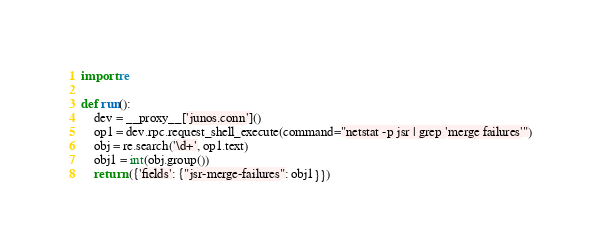Convert code to text. <code><loc_0><loc_0><loc_500><loc_500><_Python_>import re

def run():
    dev = __proxy__['junos.conn']()
    op1 = dev.rpc.request_shell_execute(command="netstat -p jsr | grep 'merge failures'")
    obj = re.search('\d+', op1.text)
    obj1 = int(obj.group())
    return ({'fields': {"jsr-merge-failures": obj1}})
</code> 